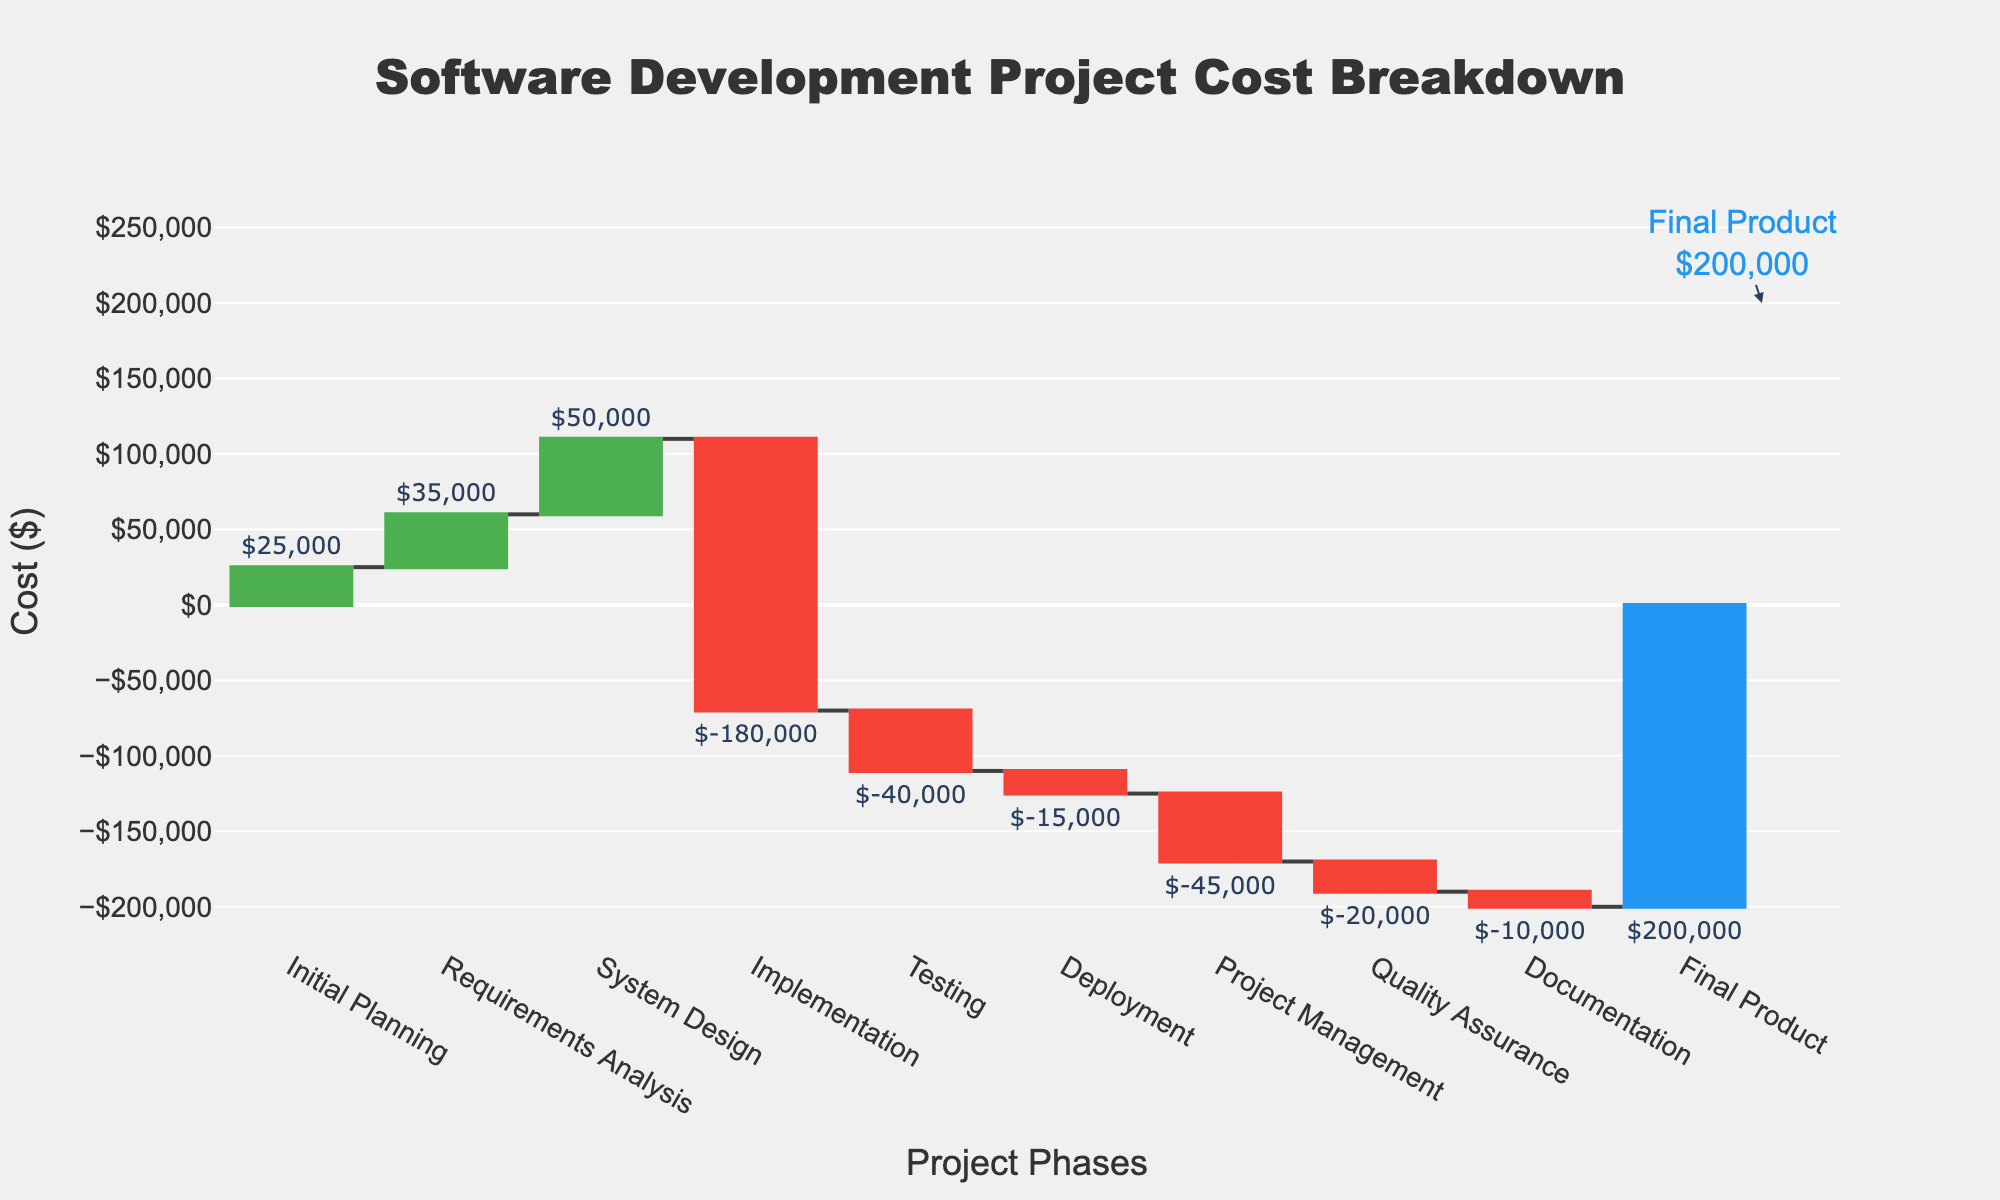What is the title of the chart? The title is placed at the top and center of the chart, and in this case, it reads "Software Development Project Cost Breakdown".
Answer: Software Development Project Cost Breakdown Which project phase has the highest individual cost? Look at the associated values next to each project phase. "Implementation" has a value of -180,000, which is the most significant in absolute terms, indicating the highest cost.
Answer: Implementation What is the cumulative cost by the end of the Testing phase? The cumulative cost by the end of the Testing phase is the sum of Initial Planning (25000), Requirements Analysis (35000), System Design (50000), Implementation (-180000), and Testing (-40000), resulting in -125,000.
Answer: -125,000 Does Deployment add or subtract from the overall project cost? The value of Deployment is shown as -15,000. Negative values in this chart indicate subtraction from the overall cost.
Answer: Subtract How much is spent or gained on Quality Assurance? The value next to Quality Assurance is -20,000, indicating that this amount is spent.
Answer: -20,000 spent Which phases have negative costs? Phases with negative costs are Implementation (-180,000), Testing (-40,000), Deployment (-15,000), Project Management (-45,000), Quality Assurance (-20,000), and Documentation (-10,000).
Answer: Implementation, Testing, Deployment, Project Management, Quality Assurance, Documentation What is the total cost accumulated up to the final product? The "Final Product" value encapsulates the total accumulated cost of the entire project, which is displayed as 200,000.
Answer: 200,000 How does the cost of System Design compare to that of Requirements Analysis and Initial Planning combined? System Design costs 50,000. The combined cost of Requirements Analysis (35,000) and Initial Planning (25,000) is 60,000. 50,000 is less than 60,000.
Answer: Less What phase follows the highest expenditure in the project? The highest expenditure is during Implementation (-180,000). Testing (-40,000) follows the Implementation phase immediately.
Answer: Testing Which category has the smallest negative cost? Among the negative cost categories, Deployment has the smallest value of -15,000.
Answer: Deployment 